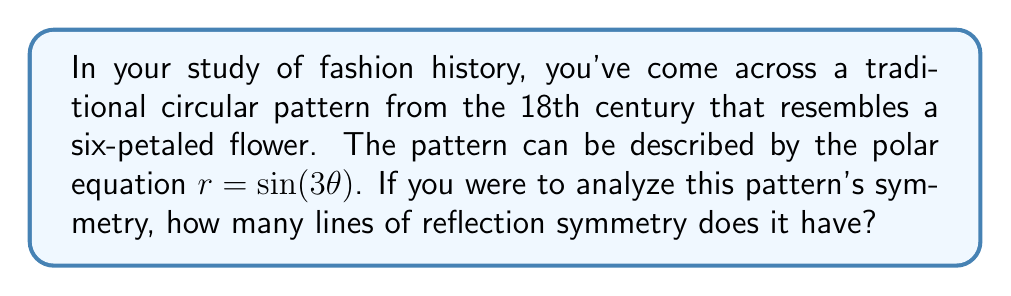Solve this math problem. To determine the number of lines of reflection symmetry for the polar equation $r = \sin(3\theta)$, we need to follow these steps:

1) First, let's understand what this equation represents:
   - The factor '3' in $\sin(3\theta)$ indicates that the pattern repeats three times as $\theta$ goes from 0 to $2\pi$.
   - This creates a six-petaled flower shape, as $\sin(3\theta)$ is positive for half of each repetition and negative for the other half.

2) In general, for equations of the form $r = \sin(n\theta)$ or $r = \cos(n\theta)$, where $n$ is a positive integer:
   - The number of petals is $2n$ if $n$ is odd.
   - The number of lines of reflection symmetry is also $2n$ if $n$ is odd.

3) In our case, $n = 3$, which is odd. Therefore:
   - The number of petals is $2(3) = 6$
   - The number of lines of reflection symmetry is also $2(3) = 6$

4) These lines of symmetry occur at angles of:
   $\frac{k\pi}{n}$, where $k = 0, 1, 2, ..., (2n-1)$

5) For $n = 3$, these angles are:
   $0, \frac{\pi}{3}, \frac{2\pi}{3}, \pi, \frac{4\pi}{3}, \frac{5\pi}{3}$

6) Visually, these lines would pass through the center of the pattern and:
   - The tips of three petals
   - The spaces between the other three petals

[asy]
import graph;
size(200);
real r(real t) {return sin(3*t);}
path g=polargraph(r,0,2pi,300);
draw(g,blue);
for(int k=0; k<6; ++k) {
  draw((0,0)--(cos(k*pi/3),sin(k*pi/3)),red+dashed);
}
[/asy]

This symmetry in historical fashion patterns often reflected cultural values of balance and harmony, which could be an interesting point for philosophical discussion in the context of fashion history.
Answer: The pattern described by $r = \sin(3\theta)$ has 6 lines of reflection symmetry. 